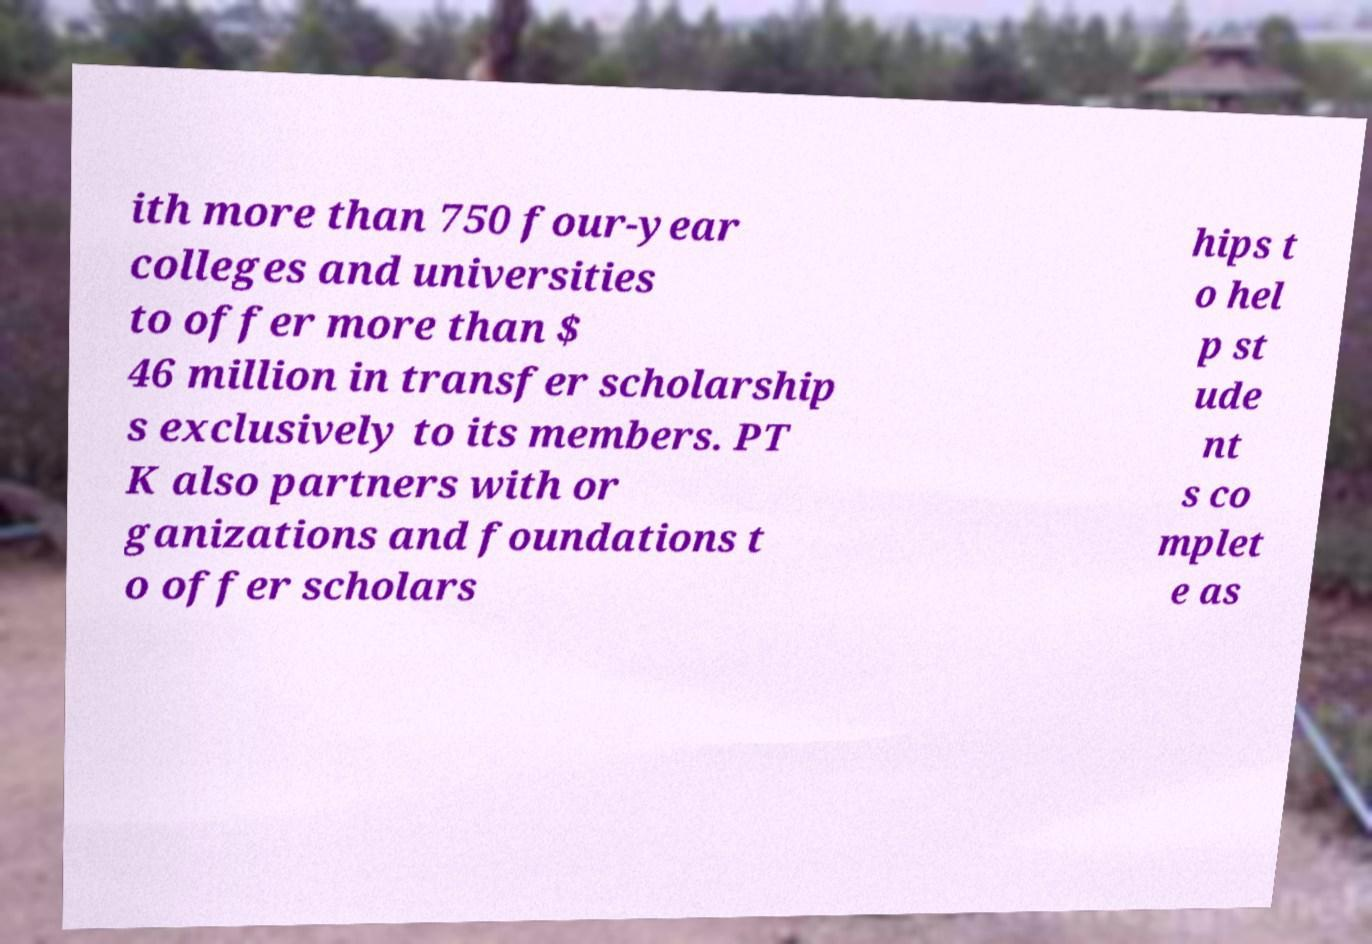Could you assist in decoding the text presented in this image and type it out clearly? ith more than 750 four-year colleges and universities to offer more than $ 46 million in transfer scholarship s exclusively to its members. PT K also partners with or ganizations and foundations t o offer scholars hips t o hel p st ude nt s co mplet e as 